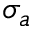<formula> <loc_0><loc_0><loc_500><loc_500>\sigma _ { a }</formula> 